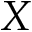<formula> <loc_0><loc_0><loc_500><loc_500>X</formula> 